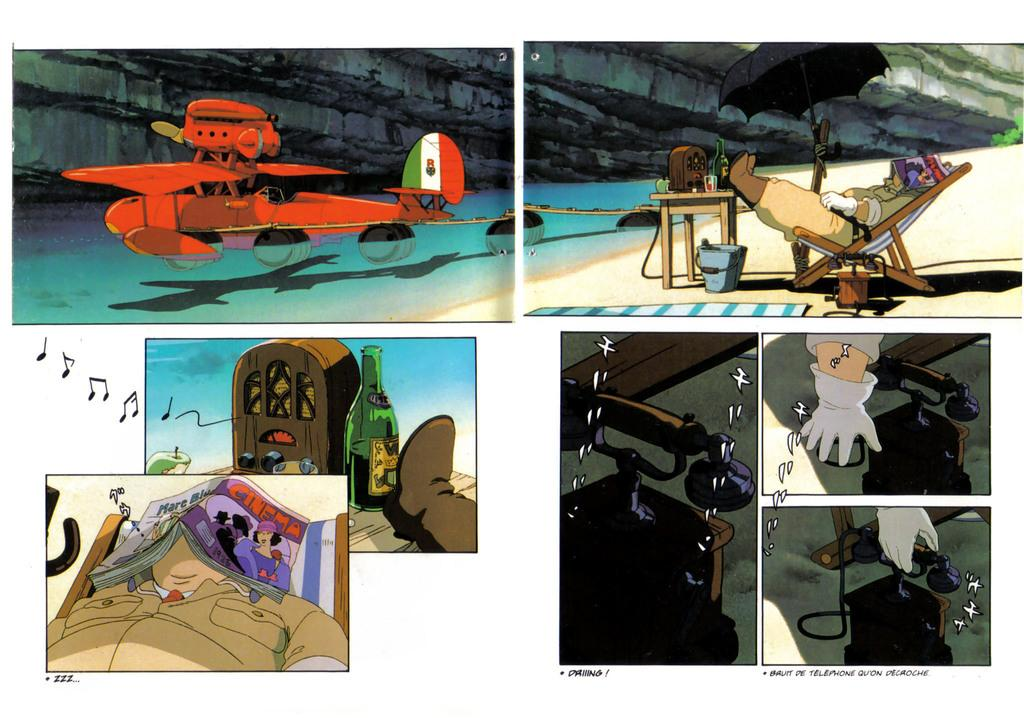<image>
Offer a succinct explanation of the picture presented. A comic book showing a red plane and a sleeping man with a Cinema magazine. 